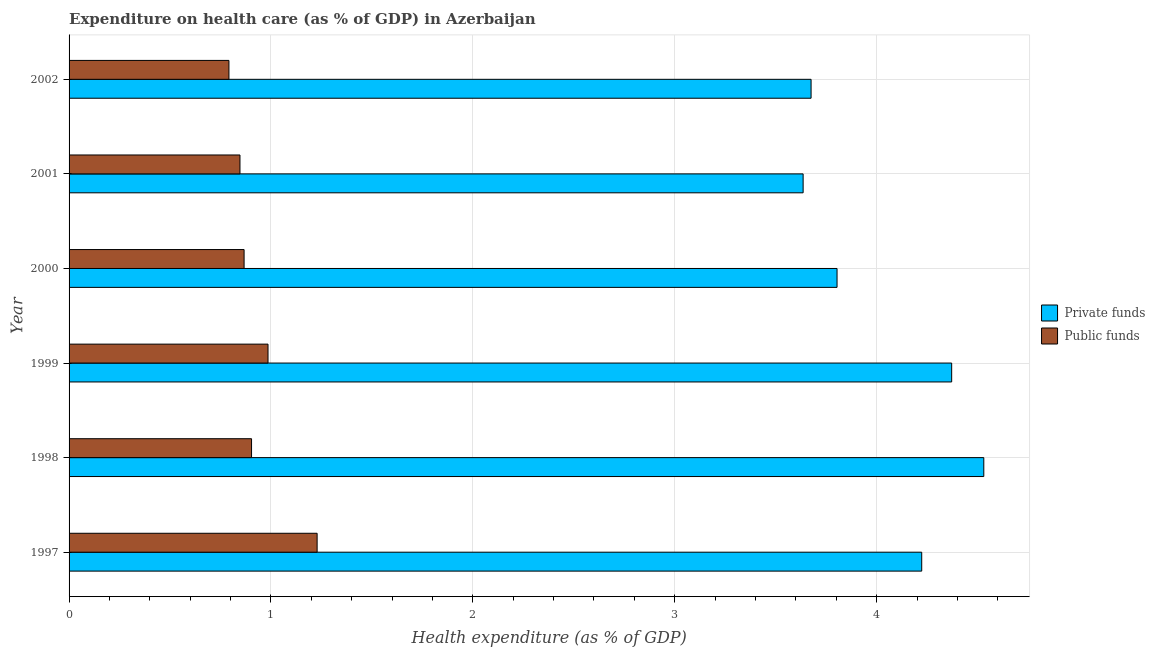Are the number of bars per tick equal to the number of legend labels?
Offer a very short reply. Yes. Are the number of bars on each tick of the Y-axis equal?
Make the answer very short. Yes. What is the label of the 4th group of bars from the top?
Offer a terse response. 1999. What is the amount of public funds spent in healthcare in 2001?
Offer a very short reply. 0.85. Across all years, what is the maximum amount of private funds spent in healthcare?
Provide a succinct answer. 4.53. Across all years, what is the minimum amount of public funds spent in healthcare?
Make the answer very short. 0.79. In which year was the amount of private funds spent in healthcare maximum?
Ensure brevity in your answer.  1998. What is the total amount of private funds spent in healthcare in the graph?
Give a very brief answer. 24.24. What is the difference between the amount of public funds spent in healthcare in 1997 and that in 1999?
Offer a very short reply. 0.24. What is the difference between the amount of public funds spent in healthcare in 2001 and the amount of private funds spent in healthcare in 1997?
Keep it short and to the point. -3.38. What is the average amount of public funds spent in healthcare per year?
Your answer should be compact. 0.94. In the year 2002, what is the difference between the amount of private funds spent in healthcare and amount of public funds spent in healthcare?
Offer a terse response. 2.88. What is the ratio of the amount of public funds spent in healthcare in 1997 to that in 1999?
Your answer should be compact. 1.25. What is the difference between the highest and the second highest amount of public funds spent in healthcare?
Offer a terse response. 0.24. What is the difference between the highest and the lowest amount of private funds spent in healthcare?
Make the answer very short. 0.89. In how many years, is the amount of private funds spent in healthcare greater than the average amount of private funds spent in healthcare taken over all years?
Your answer should be compact. 3. What does the 1st bar from the top in 1998 represents?
Offer a terse response. Public funds. What does the 2nd bar from the bottom in 2002 represents?
Your answer should be very brief. Public funds. How many bars are there?
Provide a succinct answer. 12. How many years are there in the graph?
Offer a terse response. 6. Are the values on the major ticks of X-axis written in scientific E-notation?
Ensure brevity in your answer.  No. Does the graph contain grids?
Give a very brief answer. Yes. Where does the legend appear in the graph?
Keep it short and to the point. Center right. How many legend labels are there?
Offer a very short reply. 2. How are the legend labels stacked?
Your answer should be compact. Vertical. What is the title of the graph?
Provide a short and direct response. Expenditure on health care (as % of GDP) in Azerbaijan. What is the label or title of the X-axis?
Give a very brief answer. Health expenditure (as % of GDP). What is the label or title of the Y-axis?
Make the answer very short. Year. What is the Health expenditure (as % of GDP) in Private funds in 1997?
Your answer should be very brief. 4.22. What is the Health expenditure (as % of GDP) in Public funds in 1997?
Give a very brief answer. 1.23. What is the Health expenditure (as % of GDP) in Private funds in 1998?
Keep it short and to the point. 4.53. What is the Health expenditure (as % of GDP) of Public funds in 1998?
Give a very brief answer. 0.9. What is the Health expenditure (as % of GDP) of Private funds in 1999?
Give a very brief answer. 4.37. What is the Health expenditure (as % of GDP) in Public funds in 1999?
Give a very brief answer. 0.99. What is the Health expenditure (as % of GDP) of Private funds in 2000?
Provide a short and direct response. 3.8. What is the Health expenditure (as % of GDP) in Public funds in 2000?
Provide a short and direct response. 0.87. What is the Health expenditure (as % of GDP) of Private funds in 2001?
Your answer should be very brief. 3.64. What is the Health expenditure (as % of GDP) in Public funds in 2001?
Keep it short and to the point. 0.85. What is the Health expenditure (as % of GDP) of Private funds in 2002?
Provide a short and direct response. 3.68. What is the Health expenditure (as % of GDP) of Public funds in 2002?
Offer a terse response. 0.79. Across all years, what is the maximum Health expenditure (as % of GDP) of Private funds?
Offer a very short reply. 4.53. Across all years, what is the maximum Health expenditure (as % of GDP) in Public funds?
Make the answer very short. 1.23. Across all years, what is the minimum Health expenditure (as % of GDP) of Private funds?
Your answer should be compact. 3.64. Across all years, what is the minimum Health expenditure (as % of GDP) of Public funds?
Offer a terse response. 0.79. What is the total Health expenditure (as % of GDP) of Private funds in the graph?
Provide a short and direct response. 24.24. What is the total Health expenditure (as % of GDP) in Public funds in the graph?
Keep it short and to the point. 5.62. What is the difference between the Health expenditure (as % of GDP) of Private funds in 1997 and that in 1998?
Make the answer very short. -0.31. What is the difference between the Health expenditure (as % of GDP) in Public funds in 1997 and that in 1998?
Your answer should be compact. 0.32. What is the difference between the Health expenditure (as % of GDP) of Private funds in 1997 and that in 1999?
Keep it short and to the point. -0.15. What is the difference between the Health expenditure (as % of GDP) in Public funds in 1997 and that in 1999?
Your response must be concise. 0.24. What is the difference between the Health expenditure (as % of GDP) of Private funds in 1997 and that in 2000?
Your answer should be compact. 0.42. What is the difference between the Health expenditure (as % of GDP) in Public funds in 1997 and that in 2000?
Your response must be concise. 0.36. What is the difference between the Health expenditure (as % of GDP) of Private funds in 1997 and that in 2001?
Make the answer very short. 0.59. What is the difference between the Health expenditure (as % of GDP) in Public funds in 1997 and that in 2001?
Provide a short and direct response. 0.38. What is the difference between the Health expenditure (as % of GDP) of Private funds in 1997 and that in 2002?
Give a very brief answer. 0.55. What is the difference between the Health expenditure (as % of GDP) of Public funds in 1997 and that in 2002?
Keep it short and to the point. 0.44. What is the difference between the Health expenditure (as % of GDP) in Private funds in 1998 and that in 1999?
Your answer should be compact. 0.16. What is the difference between the Health expenditure (as % of GDP) in Public funds in 1998 and that in 1999?
Give a very brief answer. -0.08. What is the difference between the Health expenditure (as % of GDP) in Private funds in 1998 and that in 2000?
Offer a very short reply. 0.73. What is the difference between the Health expenditure (as % of GDP) in Public funds in 1998 and that in 2000?
Give a very brief answer. 0.04. What is the difference between the Health expenditure (as % of GDP) of Private funds in 1998 and that in 2001?
Your answer should be very brief. 0.89. What is the difference between the Health expenditure (as % of GDP) in Public funds in 1998 and that in 2001?
Ensure brevity in your answer.  0.06. What is the difference between the Health expenditure (as % of GDP) of Private funds in 1998 and that in 2002?
Provide a short and direct response. 0.86. What is the difference between the Health expenditure (as % of GDP) in Public funds in 1998 and that in 2002?
Keep it short and to the point. 0.11. What is the difference between the Health expenditure (as % of GDP) of Private funds in 1999 and that in 2000?
Offer a very short reply. 0.57. What is the difference between the Health expenditure (as % of GDP) in Public funds in 1999 and that in 2000?
Provide a succinct answer. 0.12. What is the difference between the Health expenditure (as % of GDP) of Private funds in 1999 and that in 2001?
Provide a succinct answer. 0.74. What is the difference between the Health expenditure (as % of GDP) of Public funds in 1999 and that in 2001?
Give a very brief answer. 0.14. What is the difference between the Health expenditure (as % of GDP) of Private funds in 1999 and that in 2002?
Offer a very short reply. 0.7. What is the difference between the Health expenditure (as % of GDP) of Public funds in 1999 and that in 2002?
Your response must be concise. 0.19. What is the difference between the Health expenditure (as % of GDP) in Private funds in 2000 and that in 2001?
Offer a very short reply. 0.17. What is the difference between the Health expenditure (as % of GDP) of Public funds in 2000 and that in 2001?
Your response must be concise. 0.02. What is the difference between the Health expenditure (as % of GDP) of Private funds in 2000 and that in 2002?
Provide a succinct answer. 0.13. What is the difference between the Health expenditure (as % of GDP) in Public funds in 2000 and that in 2002?
Provide a short and direct response. 0.08. What is the difference between the Health expenditure (as % of GDP) in Private funds in 2001 and that in 2002?
Provide a short and direct response. -0.04. What is the difference between the Health expenditure (as % of GDP) of Public funds in 2001 and that in 2002?
Make the answer very short. 0.05. What is the difference between the Health expenditure (as % of GDP) in Private funds in 1997 and the Health expenditure (as % of GDP) in Public funds in 1998?
Your answer should be compact. 3.32. What is the difference between the Health expenditure (as % of GDP) of Private funds in 1997 and the Health expenditure (as % of GDP) of Public funds in 1999?
Provide a succinct answer. 3.24. What is the difference between the Health expenditure (as % of GDP) of Private funds in 1997 and the Health expenditure (as % of GDP) of Public funds in 2000?
Provide a short and direct response. 3.36. What is the difference between the Health expenditure (as % of GDP) in Private funds in 1997 and the Health expenditure (as % of GDP) in Public funds in 2001?
Your response must be concise. 3.38. What is the difference between the Health expenditure (as % of GDP) of Private funds in 1997 and the Health expenditure (as % of GDP) of Public funds in 2002?
Offer a very short reply. 3.43. What is the difference between the Health expenditure (as % of GDP) in Private funds in 1998 and the Health expenditure (as % of GDP) in Public funds in 1999?
Give a very brief answer. 3.55. What is the difference between the Health expenditure (as % of GDP) of Private funds in 1998 and the Health expenditure (as % of GDP) of Public funds in 2000?
Your response must be concise. 3.66. What is the difference between the Health expenditure (as % of GDP) in Private funds in 1998 and the Health expenditure (as % of GDP) in Public funds in 2001?
Give a very brief answer. 3.68. What is the difference between the Health expenditure (as % of GDP) in Private funds in 1998 and the Health expenditure (as % of GDP) in Public funds in 2002?
Give a very brief answer. 3.74. What is the difference between the Health expenditure (as % of GDP) in Private funds in 1999 and the Health expenditure (as % of GDP) in Public funds in 2000?
Provide a succinct answer. 3.5. What is the difference between the Health expenditure (as % of GDP) of Private funds in 1999 and the Health expenditure (as % of GDP) of Public funds in 2001?
Offer a very short reply. 3.53. What is the difference between the Health expenditure (as % of GDP) in Private funds in 1999 and the Health expenditure (as % of GDP) in Public funds in 2002?
Your answer should be very brief. 3.58. What is the difference between the Health expenditure (as % of GDP) of Private funds in 2000 and the Health expenditure (as % of GDP) of Public funds in 2001?
Your answer should be compact. 2.96. What is the difference between the Health expenditure (as % of GDP) in Private funds in 2000 and the Health expenditure (as % of GDP) in Public funds in 2002?
Ensure brevity in your answer.  3.01. What is the difference between the Health expenditure (as % of GDP) in Private funds in 2001 and the Health expenditure (as % of GDP) in Public funds in 2002?
Your answer should be compact. 2.84. What is the average Health expenditure (as % of GDP) of Private funds per year?
Your answer should be very brief. 4.04. What is the average Health expenditure (as % of GDP) of Public funds per year?
Offer a terse response. 0.94. In the year 1997, what is the difference between the Health expenditure (as % of GDP) of Private funds and Health expenditure (as % of GDP) of Public funds?
Provide a succinct answer. 2.99. In the year 1998, what is the difference between the Health expenditure (as % of GDP) of Private funds and Health expenditure (as % of GDP) of Public funds?
Provide a succinct answer. 3.63. In the year 1999, what is the difference between the Health expenditure (as % of GDP) in Private funds and Health expenditure (as % of GDP) in Public funds?
Provide a short and direct response. 3.39. In the year 2000, what is the difference between the Health expenditure (as % of GDP) in Private funds and Health expenditure (as % of GDP) in Public funds?
Provide a short and direct response. 2.94. In the year 2001, what is the difference between the Health expenditure (as % of GDP) of Private funds and Health expenditure (as % of GDP) of Public funds?
Your response must be concise. 2.79. In the year 2002, what is the difference between the Health expenditure (as % of GDP) of Private funds and Health expenditure (as % of GDP) of Public funds?
Offer a terse response. 2.88. What is the ratio of the Health expenditure (as % of GDP) in Private funds in 1997 to that in 1998?
Provide a short and direct response. 0.93. What is the ratio of the Health expenditure (as % of GDP) of Public funds in 1997 to that in 1998?
Offer a terse response. 1.36. What is the ratio of the Health expenditure (as % of GDP) in Private funds in 1997 to that in 1999?
Ensure brevity in your answer.  0.97. What is the ratio of the Health expenditure (as % of GDP) in Public funds in 1997 to that in 1999?
Give a very brief answer. 1.25. What is the ratio of the Health expenditure (as % of GDP) in Private funds in 1997 to that in 2000?
Ensure brevity in your answer.  1.11. What is the ratio of the Health expenditure (as % of GDP) of Public funds in 1997 to that in 2000?
Provide a succinct answer. 1.42. What is the ratio of the Health expenditure (as % of GDP) in Private funds in 1997 to that in 2001?
Your answer should be very brief. 1.16. What is the ratio of the Health expenditure (as % of GDP) in Public funds in 1997 to that in 2001?
Offer a terse response. 1.45. What is the ratio of the Health expenditure (as % of GDP) of Private funds in 1997 to that in 2002?
Your answer should be compact. 1.15. What is the ratio of the Health expenditure (as % of GDP) in Public funds in 1997 to that in 2002?
Your answer should be compact. 1.55. What is the ratio of the Health expenditure (as % of GDP) in Private funds in 1998 to that in 1999?
Give a very brief answer. 1.04. What is the ratio of the Health expenditure (as % of GDP) in Public funds in 1998 to that in 1999?
Keep it short and to the point. 0.92. What is the ratio of the Health expenditure (as % of GDP) of Private funds in 1998 to that in 2000?
Ensure brevity in your answer.  1.19. What is the ratio of the Health expenditure (as % of GDP) in Public funds in 1998 to that in 2000?
Provide a short and direct response. 1.04. What is the ratio of the Health expenditure (as % of GDP) in Private funds in 1998 to that in 2001?
Give a very brief answer. 1.25. What is the ratio of the Health expenditure (as % of GDP) in Public funds in 1998 to that in 2001?
Offer a very short reply. 1.07. What is the ratio of the Health expenditure (as % of GDP) of Private funds in 1998 to that in 2002?
Make the answer very short. 1.23. What is the ratio of the Health expenditure (as % of GDP) in Public funds in 1998 to that in 2002?
Your answer should be compact. 1.14. What is the ratio of the Health expenditure (as % of GDP) in Private funds in 1999 to that in 2000?
Provide a succinct answer. 1.15. What is the ratio of the Health expenditure (as % of GDP) of Public funds in 1999 to that in 2000?
Offer a very short reply. 1.14. What is the ratio of the Health expenditure (as % of GDP) of Private funds in 1999 to that in 2001?
Give a very brief answer. 1.2. What is the ratio of the Health expenditure (as % of GDP) of Public funds in 1999 to that in 2001?
Provide a short and direct response. 1.16. What is the ratio of the Health expenditure (as % of GDP) in Private funds in 1999 to that in 2002?
Provide a succinct answer. 1.19. What is the ratio of the Health expenditure (as % of GDP) of Public funds in 1999 to that in 2002?
Your response must be concise. 1.24. What is the ratio of the Health expenditure (as % of GDP) of Private funds in 2000 to that in 2001?
Provide a succinct answer. 1.05. What is the ratio of the Health expenditure (as % of GDP) of Public funds in 2000 to that in 2001?
Give a very brief answer. 1.02. What is the ratio of the Health expenditure (as % of GDP) in Private funds in 2000 to that in 2002?
Your answer should be compact. 1.03. What is the ratio of the Health expenditure (as % of GDP) of Public funds in 2000 to that in 2002?
Offer a very short reply. 1.09. What is the ratio of the Health expenditure (as % of GDP) in Private funds in 2001 to that in 2002?
Provide a succinct answer. 0.99. What is the ratio of the Health expenditure (as % of GDP) in Public funds in 2001 to that in 2002?
Your response must be concise. 1.07. What is the difference between the highest and the second highest Health expenditure (as % of GDP) in Private funds?
Keep it short and to the point. 0.16. What is the difference between the highest and the second highest Health expenditure (as % of GDP) in Public funds?
Make the answer very short. 0.24. What is the difference between the highest and the lowest Health expenditure (as % of GDP) of Private funds?
Keep it short and to the point. 0.89. What is the difference between the highest and the lowest Health expenditure (as % of GDP) in Public funds?
Provide a succinct answer. 0.44. 